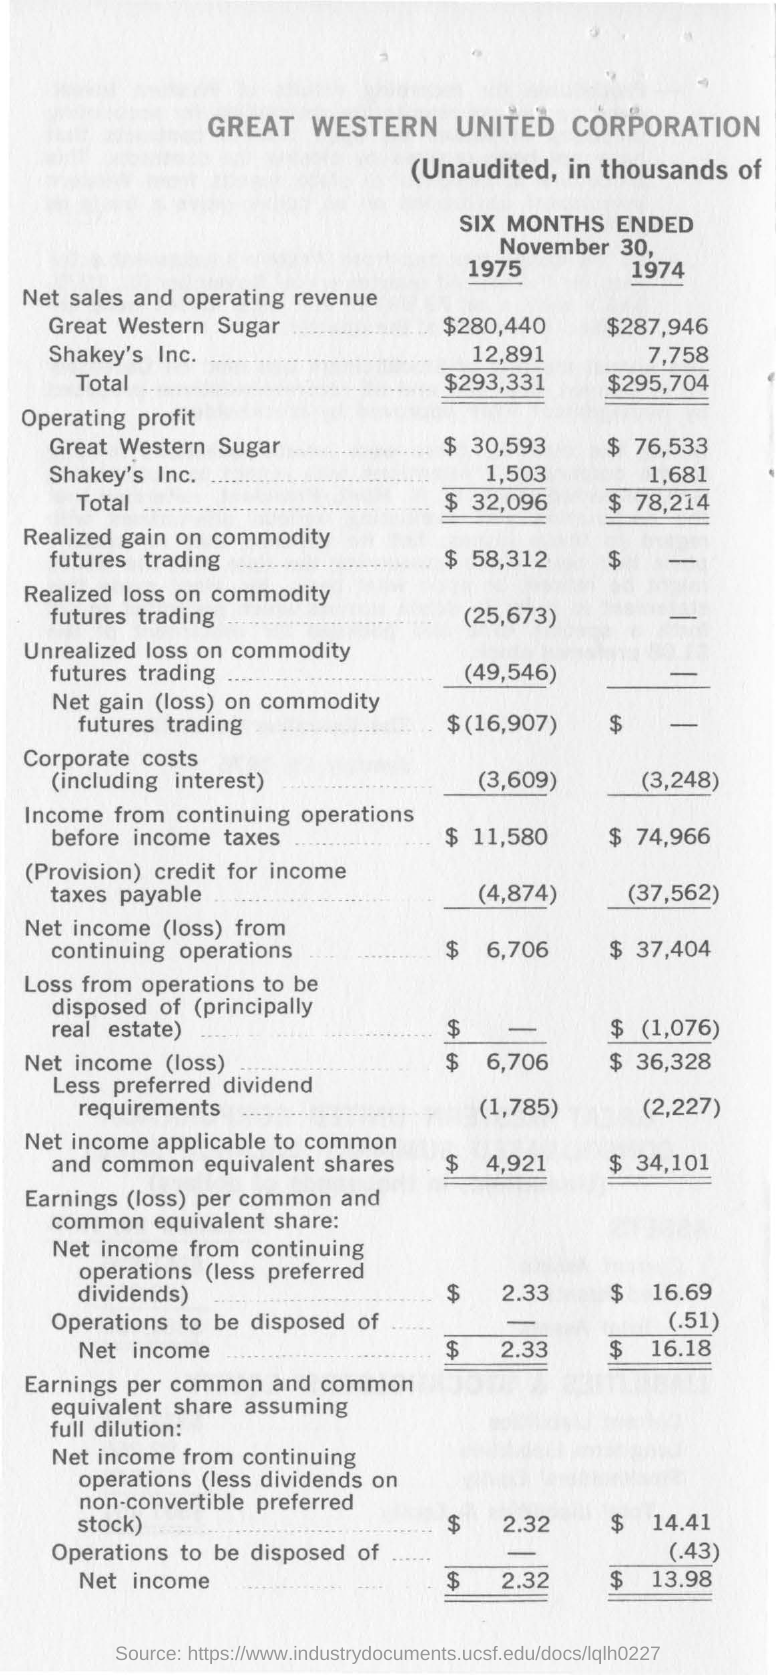What is the Net sales and operating revenue for Great Western Sugar for 1975?
Your response must be concise. $280,440. What is the Net sales and operating revenue for Great Western Sugar for 1974?
Keep it short and to the point. $287,946. What is the operating profit for Shakey's Inc. for 1974?
Your answer should be very brief. 1,681. 